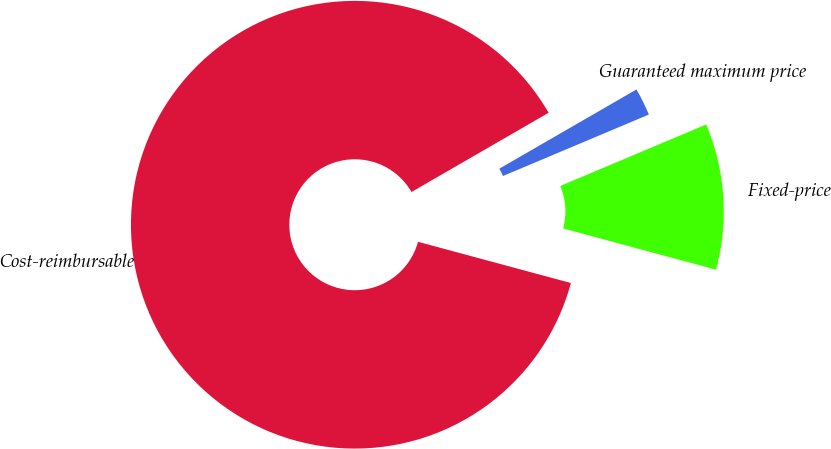Convert chart to OTSL. <chart><loc_0><loc_0><loc_500><loc_500><pie_chart><fcel>Cost-reimbursable<fcel>Fixed-price<fcel>Guaranteed maximum price<nl><fcel>87.48%<fcel>10.54%<fcel>1.99%<nl></chart> 